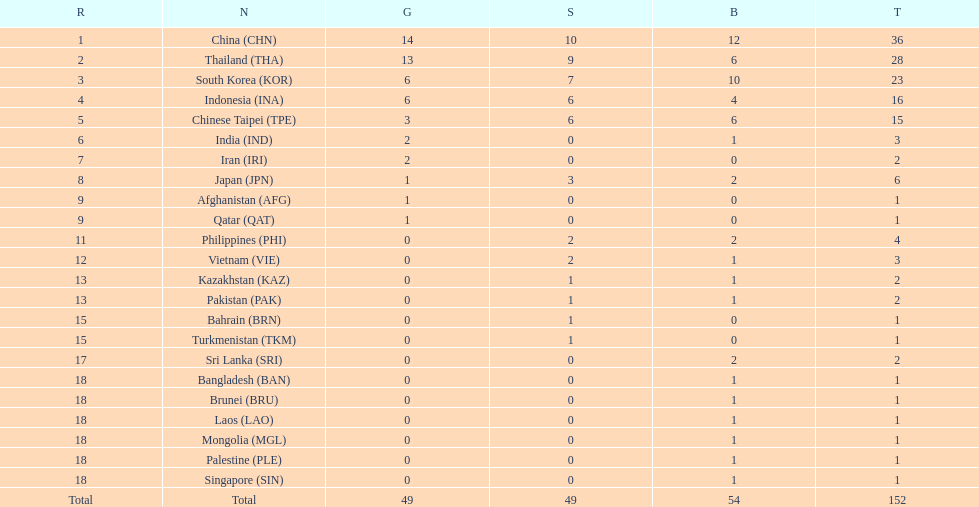Which countries won the same number of gold medals as japan? Afghanistan (AFG), Qatar (QAT). 